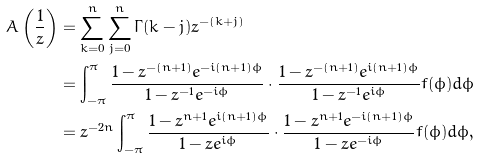<formula> <loc_0><loc_0><loc_500><loc_500>A \left ( \frac { 1 } { z } \right ) & = \sum _ { k = 0 } ^ { n } { \sum _ { j = 0 } ^ { n } { \Gamma ( k - j ) z ^ { - ( k + j ) } } } \\ & = \int _ { - \pi } ^ { \pi } \frac { 1 - z ^ { - ( n + 1 ) } e ^ { - i ( n + 1 ) \phi } } { 1 - z ^ { - 1 } e ^ { - i \phi } } \cdot \frac { 1 - z ^ { - ( n + 1 ) } e ^ { i ( n + 1 ) \phi } } { 1 - z ^ { - 1 } e ^ { i \phi } } f ( \phi ) d \phi \\ & = z ^ { - 2 n } \int _ { - \pi } ^ { \pi } \frac { 1 - z ^ { n + 1 } e ^ { i ( n + 1 ) \phi } } { 1 - z e ^ { i \phi } } \cdot \frac { 1 - z ^ { n + 1 } e ^ { - i ( n + 1 ) \phi } } { 1 - z e ^ { - i \phi } } f ( \phi ) d \phi , \\</formula> 